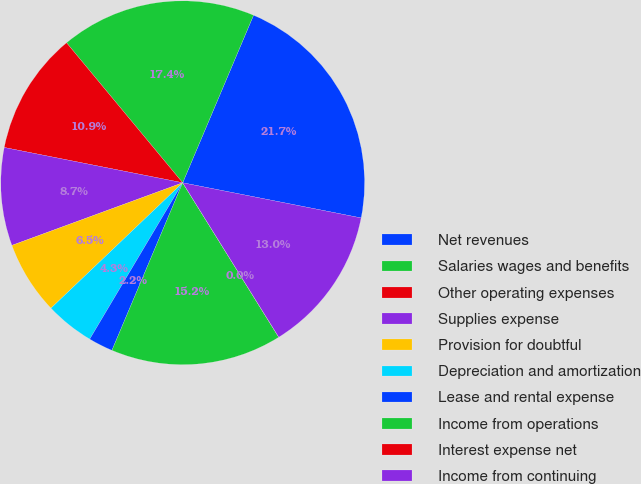Convert chart to OTSL. <chart><loc_0><loc_0><loc_500><loc_500><pie_chart><fcel>Net revenues<fcel>Salaries wages and benefits<fcel>Other operating expenses<fcel>Supplies expense<fcel>Provision for doubtful<fcel>Depreciation and amortization<fcel>Lease and rental expense<fcel>Income from operations<fcel>Interest expense net<fcel>Income from continuing<nl><fcel>21.73%<fcel>17.39%<fcel>10.87%<fcel>8.7%<fcel>6.52%<fcel>4.35%<fcel>2.18%<fcel>15.21%<fcel>0.01%<fcel>13.04%<nl></chart> 